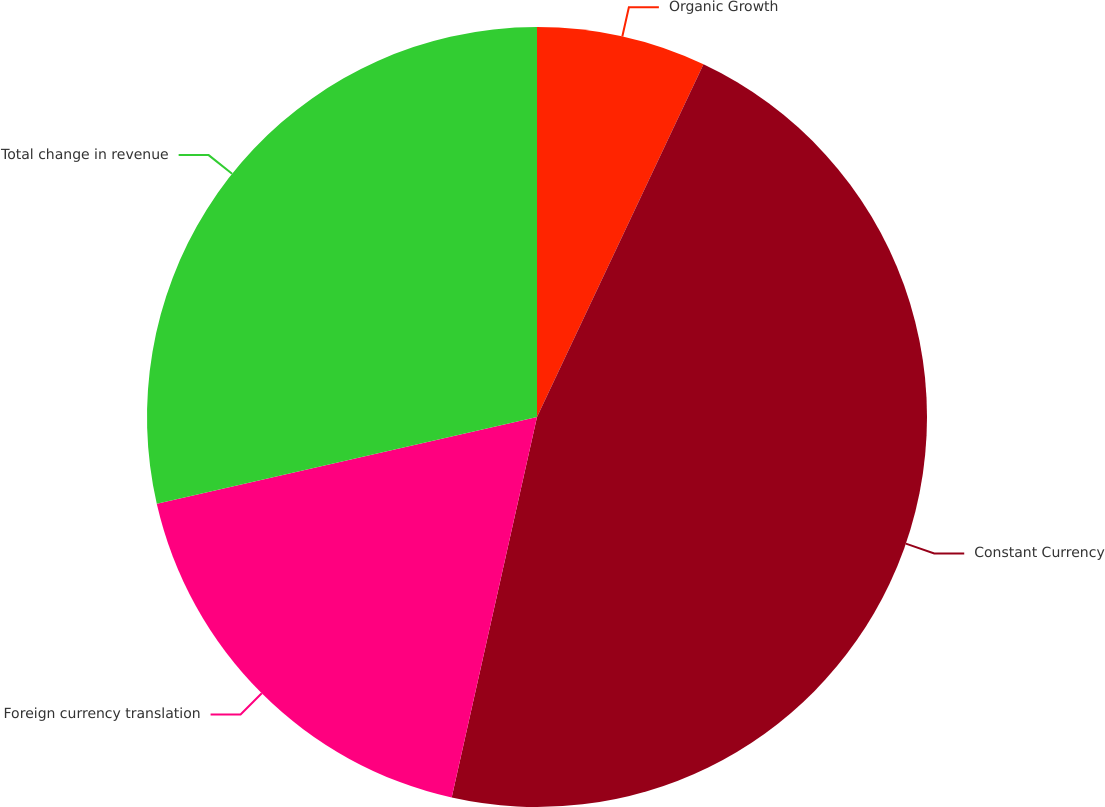<chart> <loc_0><loc_0><loc_500><loc_500><pie_chart><fcel>Organic Growth<fcel>Constant Currency<fcel>Foreign currency translation<fcel>Total change in revenue<nl><fcel>7.02%<fcel>46.49%<fcel>17.92%<fcel>28.57%<nl></chart> 